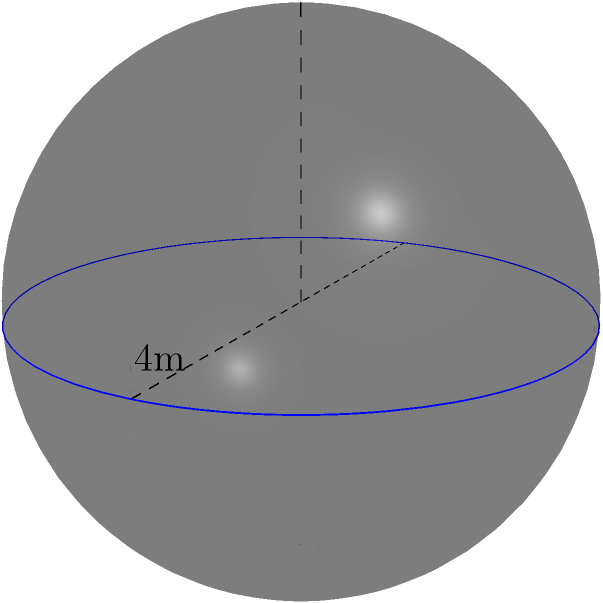As an auditor specializing in financial compliance, you're tasked with verifying the security measures for sensitive financial records. A spherical vault is used to store these records. If the diameter of the vault is 4 meters, what is the volume of the vault in cubic meters? Round your answer to two decimal places. To calculate the volume of a spherical vault, we'll follow these steps:

1) The formula for the volume of a sphere is:
   $$V = \frac{4}{3}\pi r^3$$
   where $r$ is the radius of the sphere.

2) We're given the diameter, which is 4 meters. The radius is half of the diameter:
   $$r = \frac{4}{2} = 2\text{ meters}$$

3) Now, let's substitute this into our volume formula:
   $$V = \frac{4}{3}\pi (2)^3$$

4) Simplify:
   $$V = \frac{4}{3}\pi (8)$$
   $$V = \frac{32}{3}\pi$$

5) Calculate:
   $$V \approx 33.5103\text{ cubic meters}$$

6) Rounding to two decimal places:
   $$V \approx 33.51\text{ cubic meters}$$
Answer: 33.51 cubic meters 